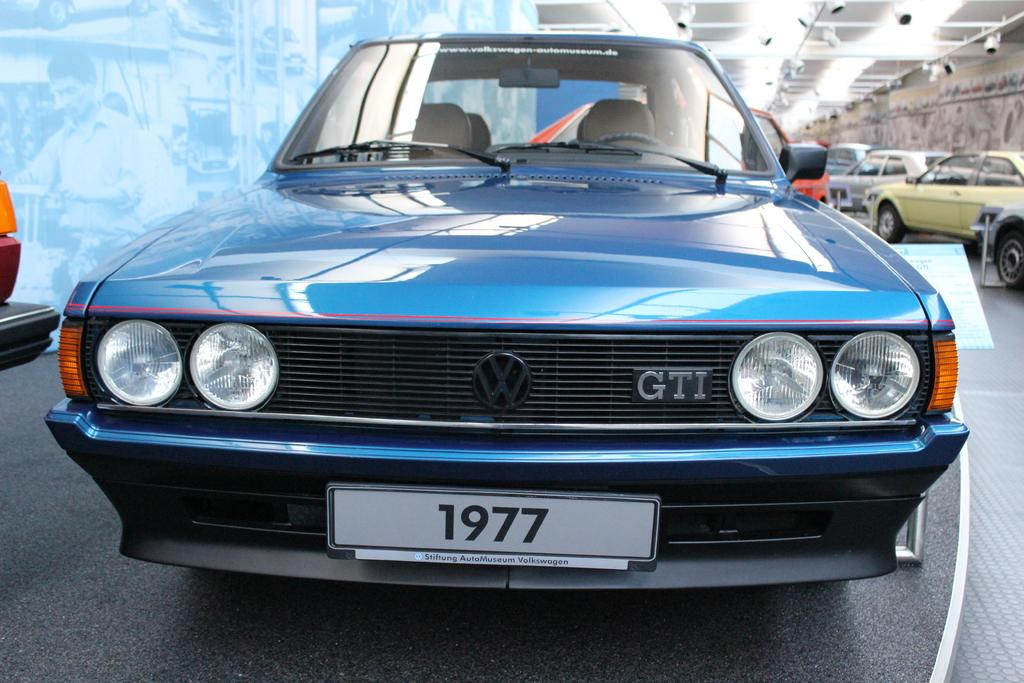What objects are on the floor in the image? There are cars on the floor in the image. What can be seen on the screen in the image? On the screen, there are two people visible and some objects visible. What is present in the background of the image? There is a wall in the image. What type of illumination is present in the image? There are lights in the image. How many dinosaurs are visible on the screen in the image? There are no dinosaurs visible on the screen in the image. What type of ring is being worn by the person on the screen? There is no ring visible on the person on the screen in the image. 